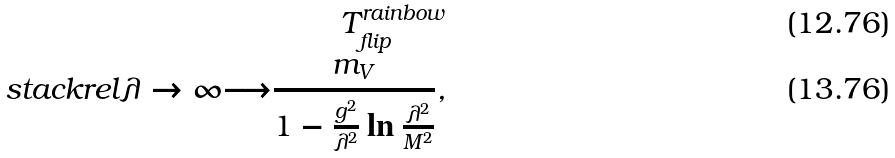<formula> <loc_0><loc_0><loc_500><loc_500>T _ { f l i p } ^ { r a i n b o w } \\ s t a c k r e l { \lambda \rightarrow \infty } { \longrightarrow } \frac { m _ { V } } { 1 - \frac { g ^ { 2 } } { \lambda ^ { 2 } } \ln \frac { \lambda ^ { 2 } } { M ^ { 2 } } } ,</formula> 